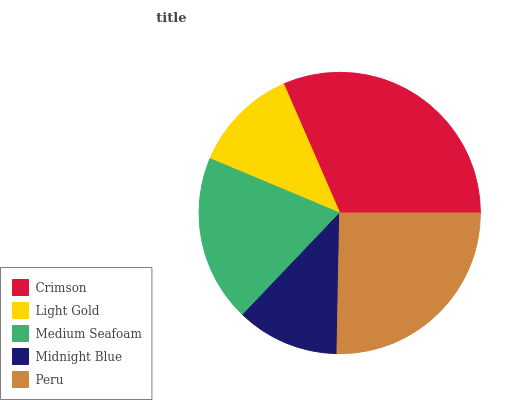Is Midnight Blue the minimum?
Answer yes or no. Yes. Is Crimson the maximum?
Answer yes or no. Yes. Is Light Gold the minimum?
Answer yes or no. No. Is Light Gold the maximum?
Answer yes or no. No. Is Crimson greater than Light Gold?
Answer yes or no. Yes. Is Light Gold less than Crimson?
Answer yes or no. Yes. Is Light Gold greater than Crimson?
Answer yes or no. No. Is Crimson less than Light Gold?
Answer yes or no. No. Is Medium Seafoam the high median?
Answer yes or no. Yes. Is Medium Seafoam the low median?
Answer yes or no. Yes. Is Midnight Blue the high median?
Answer yes or no. No. Is Peru the low median?
Answer yes or no. No. 